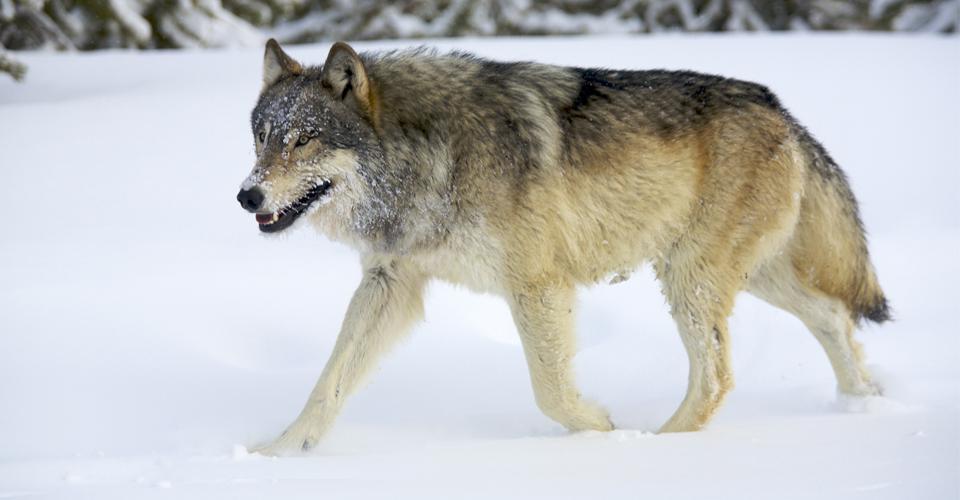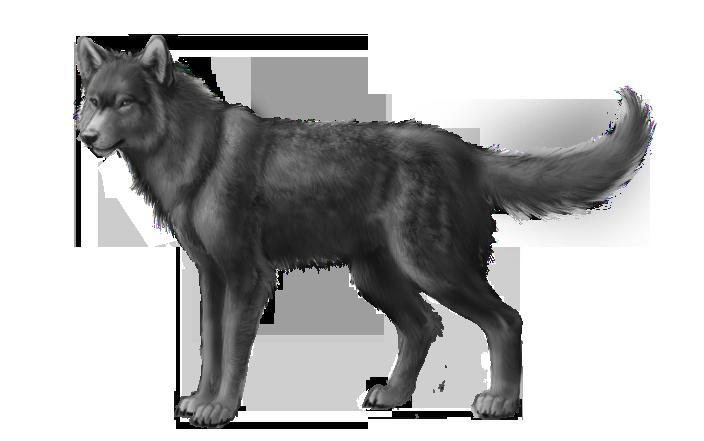The first image is the image on the left, the second image is the image on the right. Considering the images on both sides, is "The animal in the image on the left is moving left." valid? Answer yes or no. Yes. 